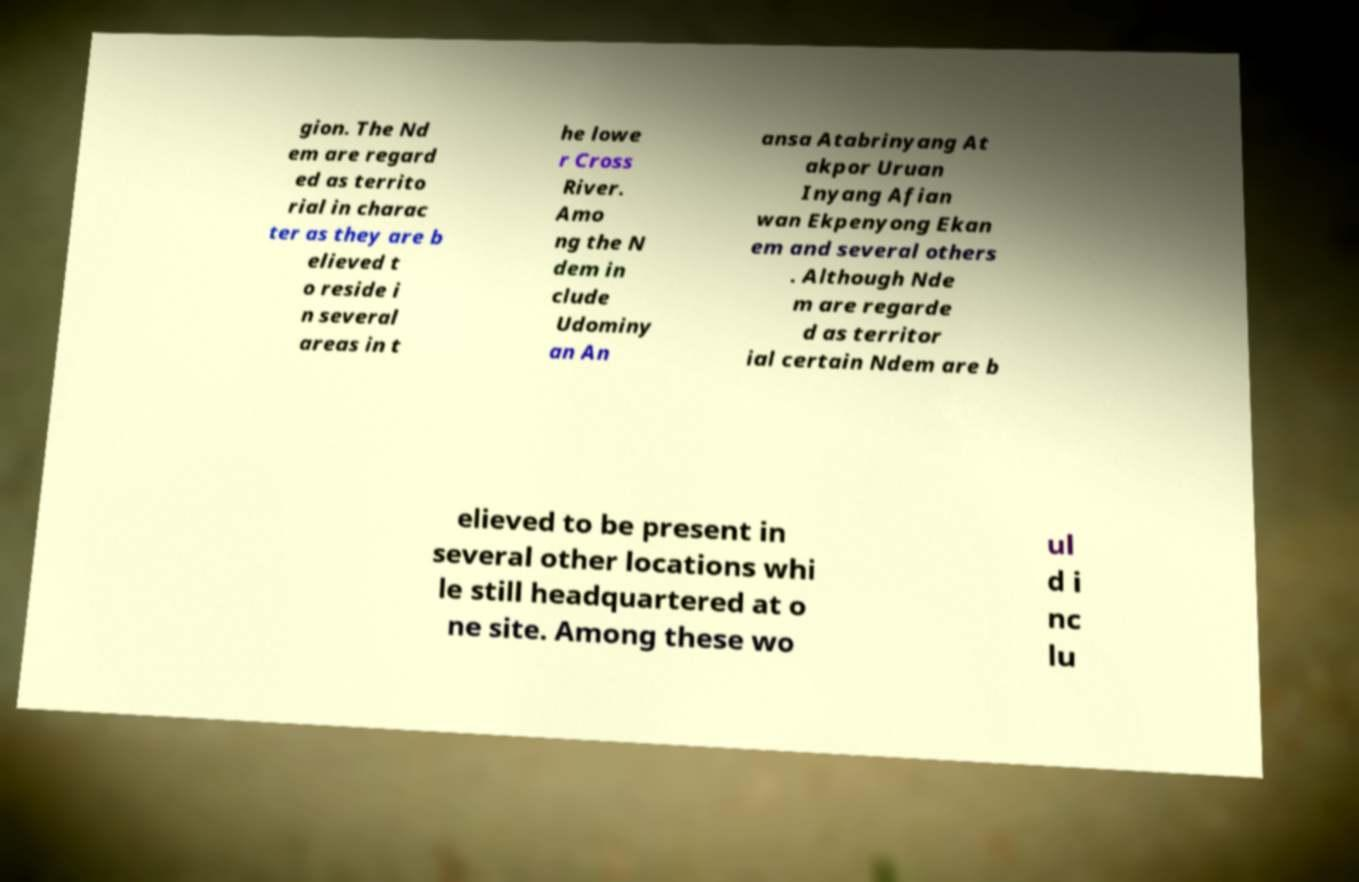There's text embedded in this image that I need extracted. Can you transcribe it verbatim? gion. The Nd em are regard ed as territo rial in charac ter as they are b elieved t o reside i n several areas in t he lowe r Cross River. Amo ng the N dem in clude Udominy an An ansa Atabrinyang At akpor Uruan Inyang Afian wan Ekpenyong Ekan em and several others . Although Nde m are regarde d as territor ial certain Ndem are b elieved to be present in several other locations whi le still headquartered at o ne site. Among these wo ul d i nc lu 